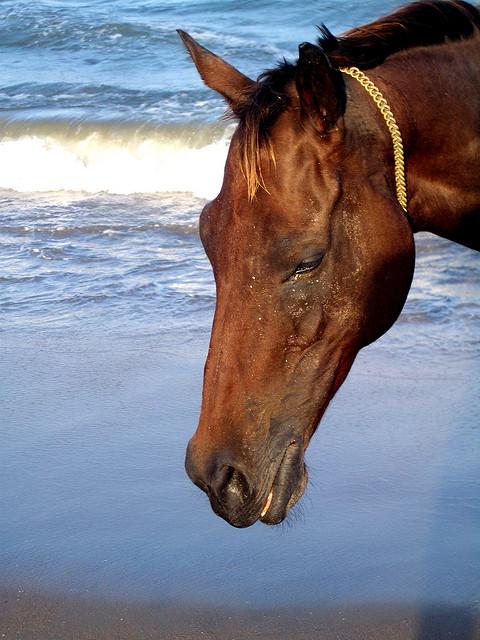Is the horse drinking?
Concise answer only. No. Does the horse look tired?
Answer briefly. Yes. Is the horse wearing something on it's neck?
Answer briefly. Yes. What is the horse wearing on its head?
Keep it brief. Hair. 